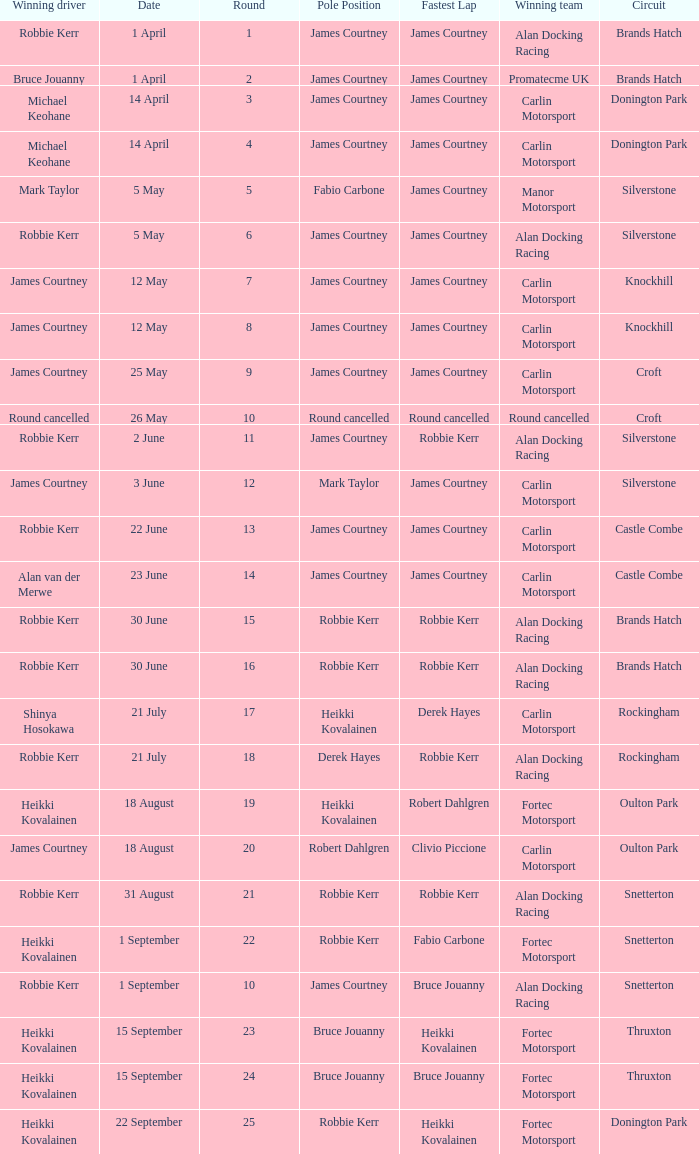How many rounds have Fabio Carbone for fastest lap? 1.0. 